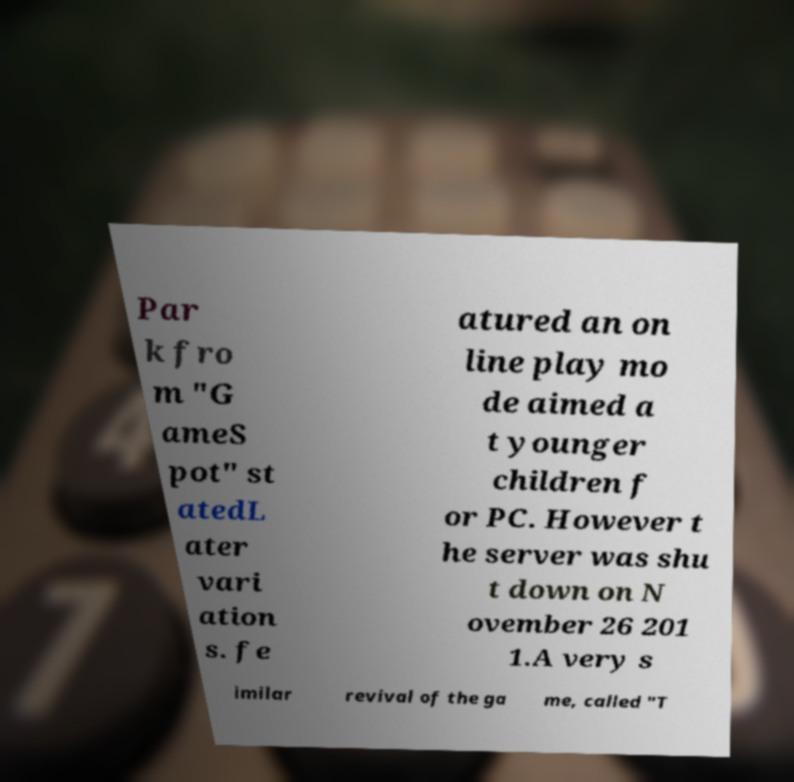Could you extract and type out the text from this image? Par k fro m "G ameS pot" st atedL ater vari ation s. fe atured an on line play mo de aimed a t younger children f or PC. However t he server was shu t down on N ovember 26 201 1.A very s imilar revival of the ga me, called "T 